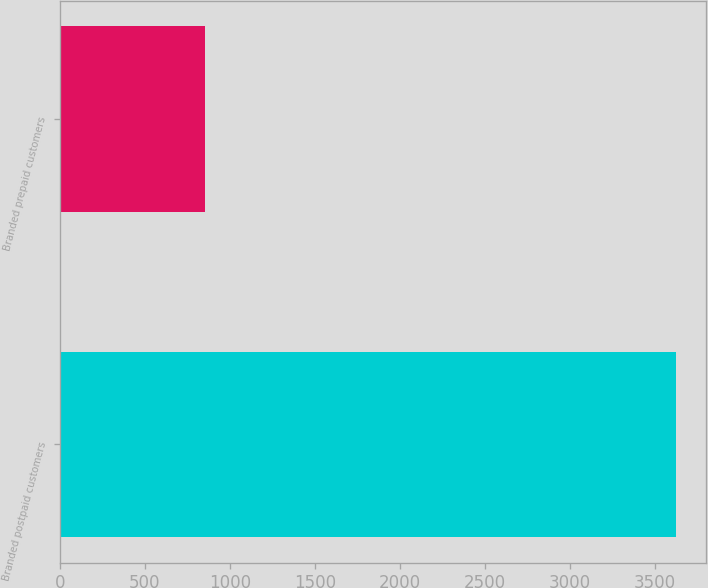Convert chart to OTSL. <chart><loc_0><loc_0><loc_500><loc_500><bar_chart><fcel>Branded postpaid customers<fcel>Branded prepaid customers<nl><fcel>3620<fcel>855<nl></chart> 